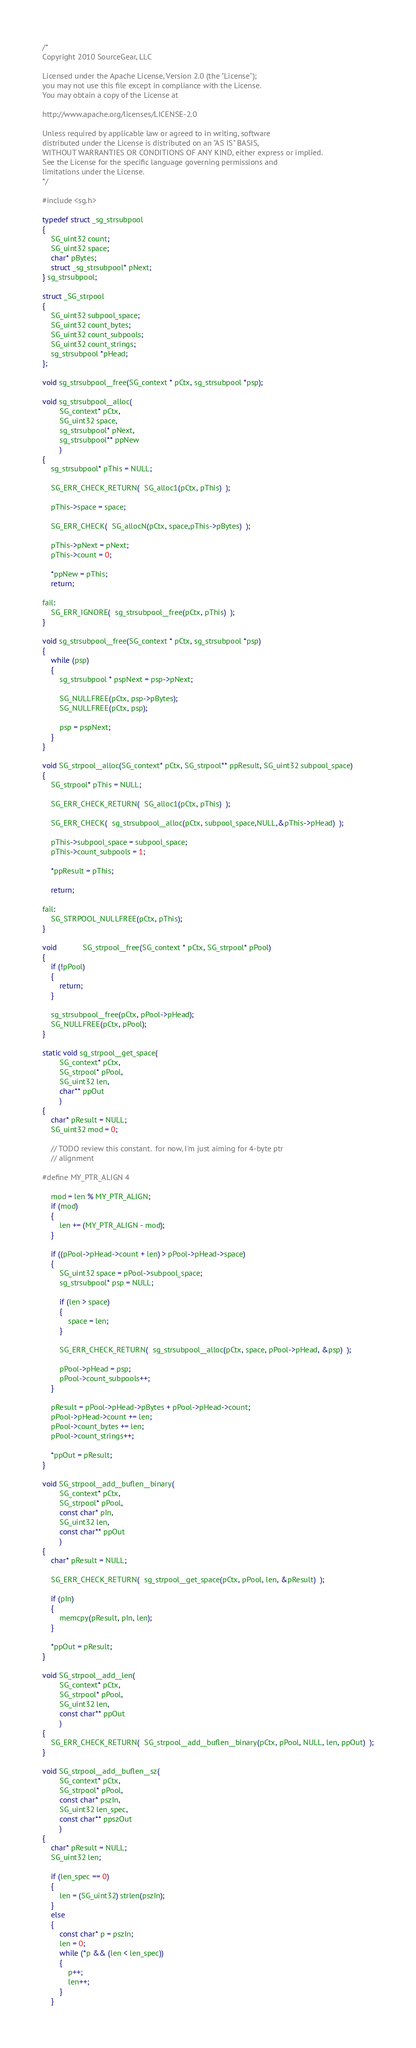Convert code to text. <code><loc_0><loc_0><loc_500><loc_500><_C_>/*
Copyright 2010 SourceGear, LLC

Licensed under the Apache License, Version 2.0 (the "License");
you may not use this file except in compliance with the License.
You may obtain a copy of the License at

http://www.apache.org/licenses/LICENSE-2.0

Unless required by applicable law or agreed to in writing, software
distributed under the License is distributed on an "AS IS" BASIS,
WITHOUT WARRANTIES OR CONDITIONS OF ANY KIND, either express or implied.
See the License for the specific language governing permissions and
limitations under the License.
*/

#include <sg.h>

typedef struct _sg_strsubpool
{
	SG_uint32 count;
	SG_uint32 space;
	char* pBytes;
	struct _sg_strsubpool* pNext;
} sg_strsubpool;

struct _SG_strpool
{
	SG_uint32 subpool_space;
	SG_uint32 count_bytes;
	SG_uint32 count_subpools;
	SG_uint32 count_strings;
	sg_strsubpool *pHead;
};

void sg_strsubpool__free(SG_context * pCtx, sg_strsubpool *psp);

void sg_strsubpool__alloc(
        SG_context* pCtx,
        SG_uint32 space,
        sg_strsubpool* pNext,
        sg_strsubpool** ppNew
        )
{
	sg_strsubpool* pThis = NULL;

	SG_ERR_CHECK_RETURN(  SG_alloc1(pCtx, pThis)  );

	pThis->space = space;

	SG_ERR_CHECK(  SG_allocN(pCtx, space,pThis->pBytes)  );

	pThis->pNext = pNext;
	pThis->count = 0;

	*ppNew = pThis;
	return;

fail:
	SG_ERR_IGNORE(  sg_strsubpool__free(pCtx, pThis)  );
}

void sg_strsubpool__free(SG_context * pCtx, sg_strsubpool *psp)
{
	while (psp)
	{
		sg_strsubpool * pspNext = psp->pNext;

		SG_NULLFREE(pCtx, psp->pBytes);
		SG_NULLFREE(pCtx, psp);

		psp = pspNext;
	}
}

void SG_strpool__alloc(SG_context* pCtx, SG_strpool** ppResult, SG_uint32 subpool_space)
{
	SG_strpool* pThis = NULL;

	SG_ERR_CHECK_RETURN(  SG_alloc1(pCtx, pThis)  );

	SG_ERR_CHECK(  sg_strsubpool__alloc(pCtx, subpool_space,NULL,&pThis->pHead)  );

	pThis->subpool_space = subpool_space;
	pThis->count_subpools = 1;

	*ppResult = pThis;

	return;

fail:
	SG_STRPOOL_NULLFREE(pCtx, pThis);
}

void            SG_strpool__free(SG_context * pCtx, SG_strpool* pPool)
{
	if (!pPool)
	{
		return;
	}

	sg_strsubpool__free(pCtx, pPool->pHead);
	SG_NULLFREE(pCtx, pPool);
}

static void sg_strpool__get_space(
        SG_context* pCtx,
        SG_strpool* pPool,
        SG_uint32 len,
        char** ppOut
        )
{
	char* pResult = NULL;
    SG_uint32 mod = 0;

    // TODO review this constant.  for now, I'm just aiming for 4-byte ptr
    // alignment

#define MY_PTR_ALIGN 4

    mod = len % MY_PTR_ALIGN;
    if (mod)
    {
        len += (MY_PTR_ALIGN - mod);
    }

	if ((pPool->pHead->count + len) > pPool->pHead->space)
	{
		SG_uint32 space = pPool->subpool_space;
		sg_strsubpool* psp = NULL;

		if (len > space)
		{
			space = len;
		}

		SG_ERR_CHECK_RETURN(  sg_strsubpool__alloc(pCtx, space, pPool->pHead, &psp)  );

		pPool->pHead = psp;
		pPool->count_subpools++;
	}

	pResult = pPool->pHead->pBytes + pPool->pHead->count;
	pPool->pHead->count += len;
	pPool->count_bytes += len;
	pPool->count_strings++;

	*ppOut = pResult;
}

void SG_strpool__add__buflen__binary(
        SG_context* pCtx,
        SG_strpool* pPool,
        const char* pIn,
        SG_uint32 len,
        const char** ppOut
        )
{
	char* pResult = NULL;

    SG_ERR_CHECK_RETURN(  sg_strpool__get_space(pCtx, pPool, len, &pResult)  );

	if (pIn)
	{
		memcpy(pResult, pIn, len);
	}

	*ppOut = pResult;
}

void SG_strpool__add__len(
        SG_context* pCtx,
        SG_strpool* pPool,
        SG_uint32 len,
        const char** ppOut
        )
{
	SG_ERR_CHECK_RETURN(  SG_strpool__add__buflen__binary(pCtx, pPool, NULL, len, ppOut)  );
}

void SG_strpool__add__buflen__sz(
        SG_context* pCtx,
        SG_strpool* pPool,
        const char* pszIn,
        SG_uint32 len_spec,
        const char** ppszOut
        )
{
	char* pResult = NULL;
	SG_uint32 len;

	if (len_spec == 0)
	{
		len = (SG_uint32) strlen(pszIn);
	}
	else
	{
		const char* p = pszIn;
		len = 0;
		while (*p && (len < len_spec))
		{
			p++;
			len++;
		}
	}
</code> 